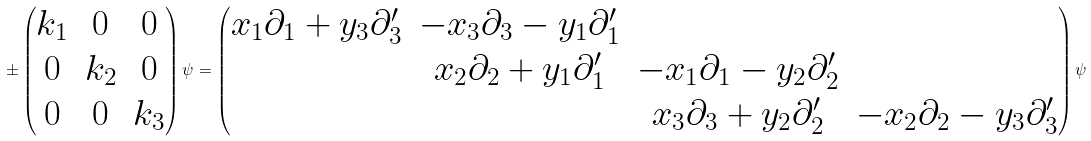Convert formula to latex. <formula><loc_0><loc_0><loc_500><loc_500>\pm \begin{pmatrix} k _ { 1 } & 0 & 0 \\ 0 & k _ { 2 } & 0 \\ 0 & 0 & k _ { 3 } \end{pmatrix} \psi = \begin{pmatrix} x _ { 1 } \partial _ { 1 } + y _ { 3 } \partial ^ { \prime } _ { 3 } & - x _ { 3 } \partial _ { 3 } - y _ { 1 } \partial ^ { \prime } _ { 1 } & & \\ & x _ { 2 } \partial _ { 2 } + y _ { 1 } \partial ^ { \prime } _ { 1 } & - x _ { 1 } \partial _ { 1 } - y _ { 2 } \partial ^ { \prime } _ { 2 } & \\ & & x _ { 3 } \partial _ { 3 } + y _ { 2 } \partial ^ { \prime } _ { 2 } & - x _ { 2 } \partial _ { 2 } - y _ { 3 } \partial ^ { \prime } _ { 3 } \end{pmatrix} \psi</formula> 